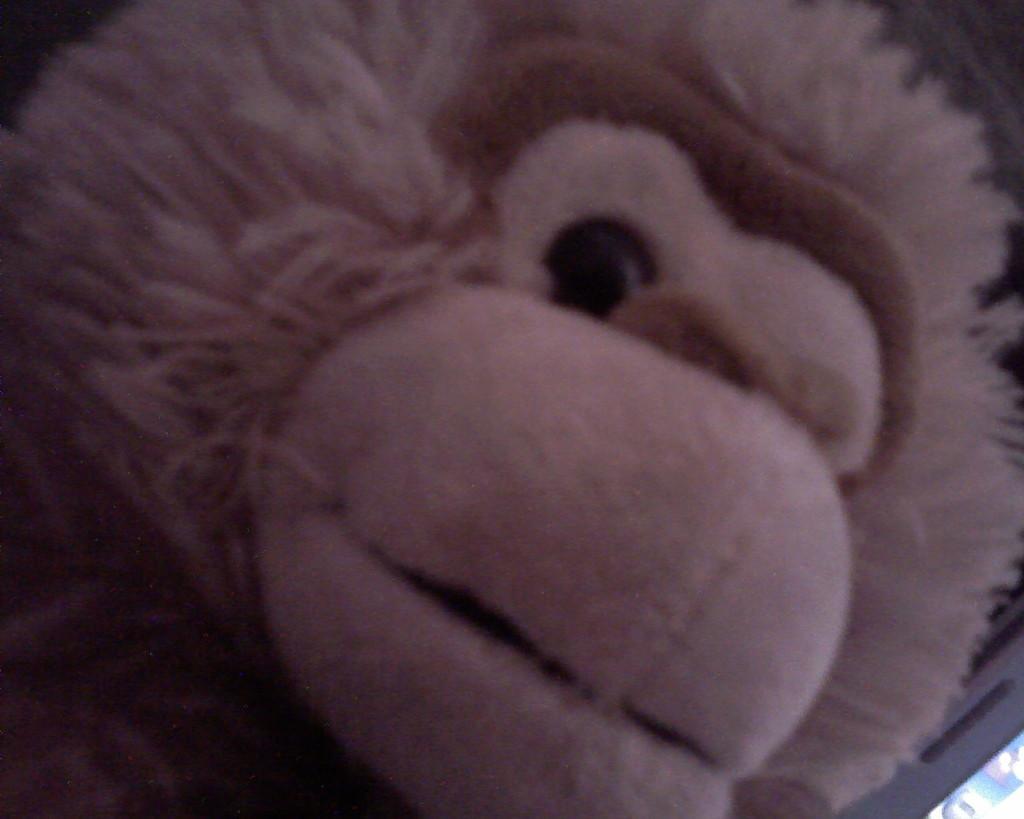In one or two sentences, can you explain what this image depicts? In this picture we can observe a toy which is in cream color. We can observe fur on this toy. This toy is looking like a monkey. 